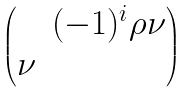<formula> <loc_0><loc_0><loc_500><loc_500>\begin{pmatrix} & ( - 1 ) ^ { i } \rho \nu \\ \nu & \end{pmatrix}</formula> 